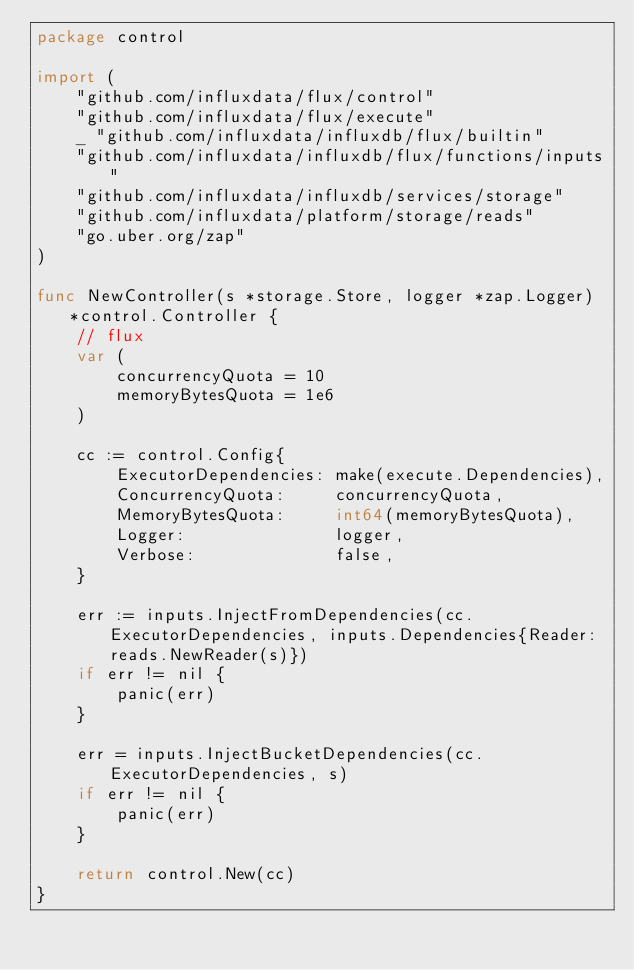Convert code to text. <code><loc_0><loc_0><loc_500><loc_500><_Go_>package control

import (
	"github.com/influxdata/flux/control"
	"github.com/influxdata/flux/execute"
	_ "github.com/influxdata/influxdb/flux/builtin"
	"github.com/influxdata/influxdb/flux/functions/inputs"
	"github.com/influxdata/influxdb/services/storage"
	"github.com/influxdata/platform/storage/reads"
	"go.uber.org/zap"
)

func NewController(s *storage.Store, logger *zap.Logger) *control.Controller {
	// flux
	var (
		concurrencyQuota = 10
		memoryBytesQuota = 1e6
	)

	cc := control.Config{
		ExecutorDependencies: make(execute.Dependencies),
		ConcurrencyQuota:     concurrencyQuota,
		MemoryBytesQuota:     int64(memoryBytesQuota),
		Logger:               logger,
		Verbose:              false,
	}

	err := inputs.InjectFromDependencies(cc.ExecutorDependencies, inputs.Dependencies{Reader: reads.NewReader(s)})
	if err != nil {
		panic(err)
	}

	err = inputs.InjectBucketDependencies(cc.ExecutorDependencies, s)
	if err != nil {
		panic(err)
	}

	return control.New(cc)
}
</code> 